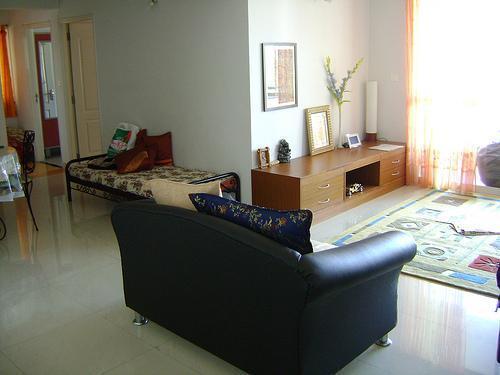How many pictures are there?
Give a very brief answer. 4. 